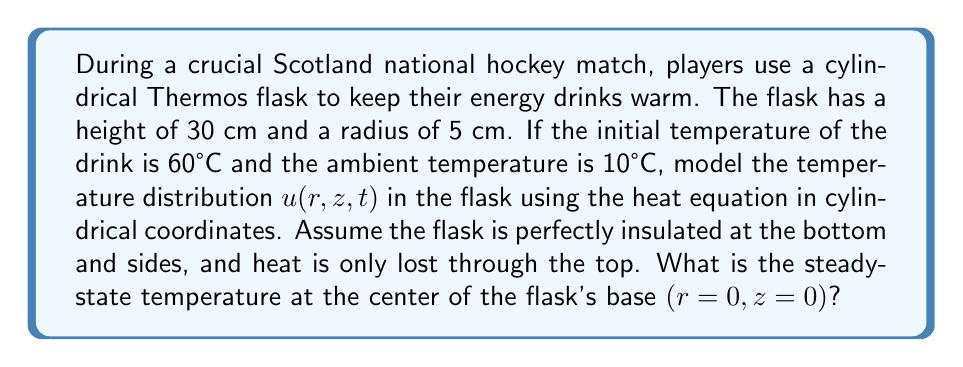Can you answer this question? Let's approach this step-by-step:

1) The heat equation in cylindrical coordinates is:

   $$\frac{\partial u}{\partial t} = \alpha \left(\frac{1}{r}\frac{\partial}{\partial r}\left(r\frac{\partial u}{\partial r}\right) + \frac{\partial^2 u}{\partial z^2}\right)$$

2) Given the insulation conditions, we have the following boundary conditions:
   
   At $r = R$ (side): $\frac{\partial u}{\partial r} = 0$
   At $z = 0$ (bottom): $\frac{\partial u}{\partial z} = 0$
   At $z = H$ (top): $-k\frac{\partial u}{\partial z} = h(u - T_a)$

   Where $R = 5$ cm, $H = 30$ cm, and $T_a = 10°C$ (ambient temperature)

3) For steady-state, $\frac{\partial u}{\partial t} = 0$, so our equation becomes:

   $$\frac{1}{r}\frac{\partial}{\partial r}\left(r\frac{\partial u}{\partial r}\right) + \frac{\partial^2 u}{\partial z^2} = 0$$

4) Given the symmetry and insulation of the flask, we can assume that the temperature only varies with height $z$. So, $\frac{\partial u}{\partial r} = 0$, and our equation simplifies to:

   $$\frac{d^2 u}{dz^2} = 0$$

5) The general solution to this is:

   $$u(z) = Az + B$$

6) Applying the boundary conditions:
   At $z = 0$: $\frac{du}{dz} = A = 0$
   At $z = H$: $-k\frac{du}{dz} = h(u - T_a)$

7) From the first condition, $A = 0$, so $u(z) = B$ (constant temperature throughout)

8) From the second condition:
   $0 = h(B - T_a)$
   $B = T_a = 10°C$

9) Therefore, the steady-state temperature throughout the flask, including at the center of the base $(r=0, z=0)$, is 10°C.
Answer: 10°C 